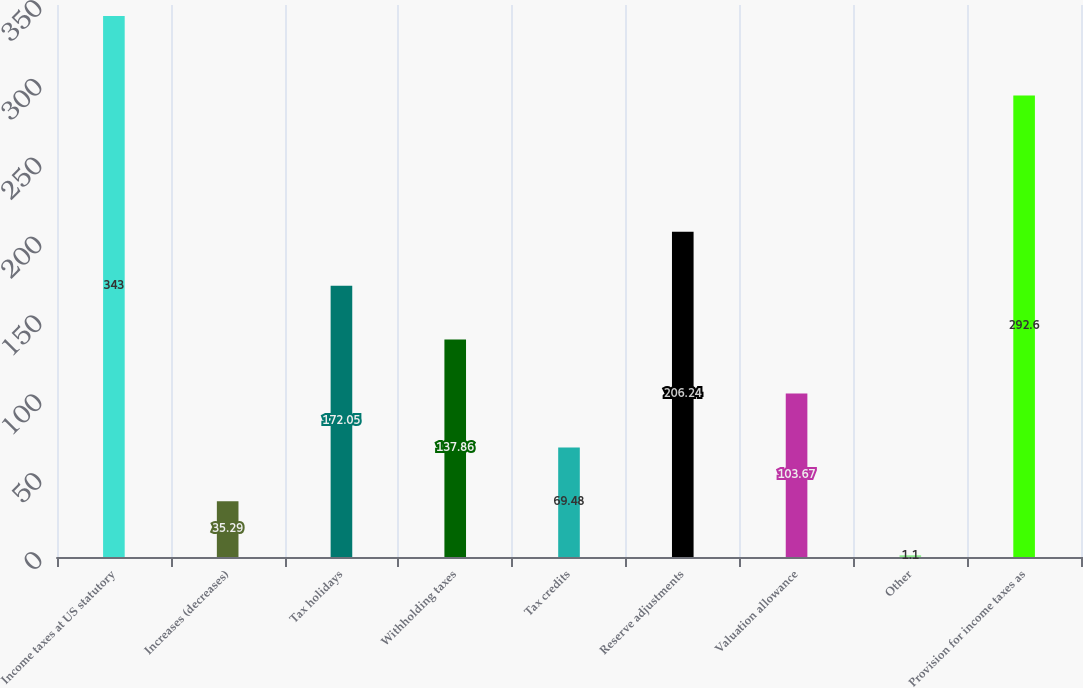Convert chart. <chart><loc_0><loc_0><loc_500><loc_500><bar_chart><fcel>Income taxes at US statutory<fcel>Increases (decreases)<fcel>Tax holidays<fcel>Withholding taxes<fcel>Tax credits<fcel>Reserve adjustments<fcel>Valuation allowance<fcel>Other<fcel>Provision for income taxes as<nl><fcel>343<fcel>35.29<fcel>172.05<fcel>137.86<fcel>69.48<fcel>206.24<fcel>103.67<fcel>1.1<fcel>292.6<nl></chart> 